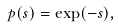Convert formula to latex. <formula><loc_0><loc_0><loc_500><loc_500>p ( s ) = \exp ( - s ) ,</formula> 